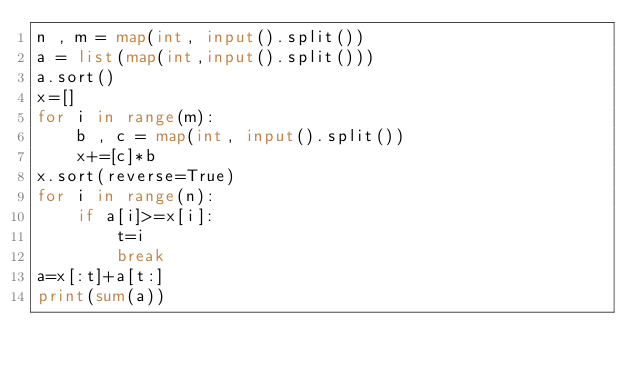<code> <loc_0><loc_0><loc_500><loc_500><_Python_>n , m = map(int, input().split())
a = list(map(int,input().split()))
a.sort()
x=[]
for i in range(m):
    b , c = map(int, input().split())
    x+=[c]*b
x.sort(reverse=True)
for i in range(n):
    if a[i]>=x[i]:
        t=i
        break
a=x[:t]+a[t:]
print(sum(a))
</code> 